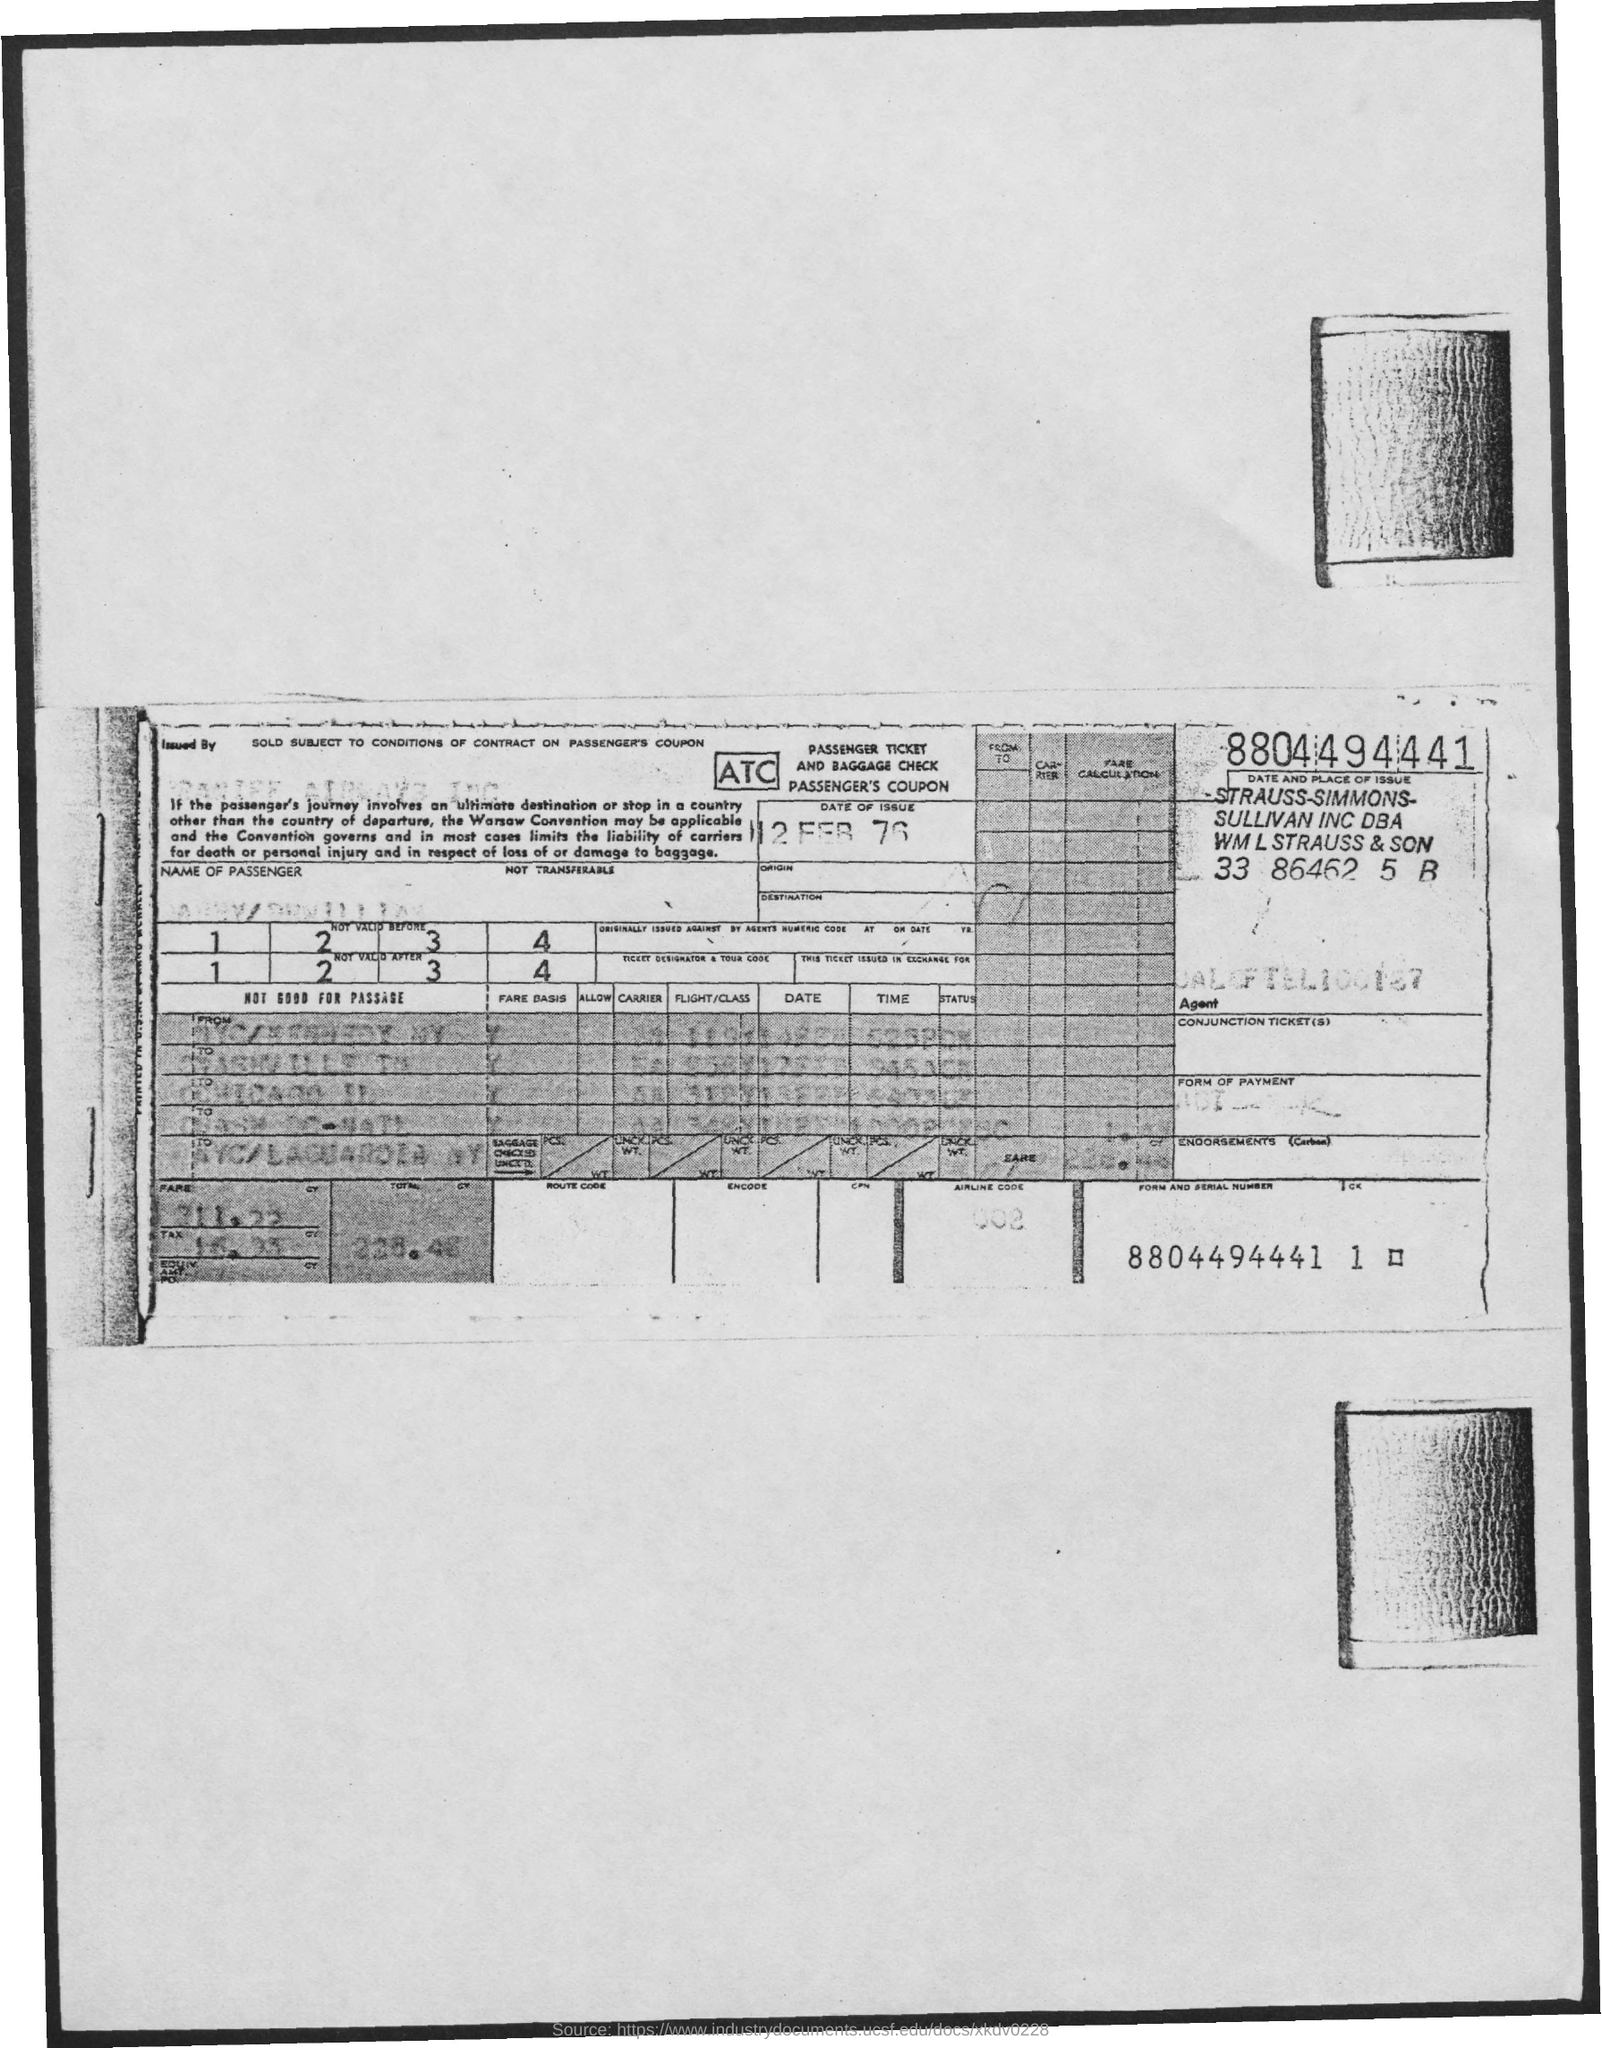Specify some key components in this picture. The date of the issue is February 12, 1976. 